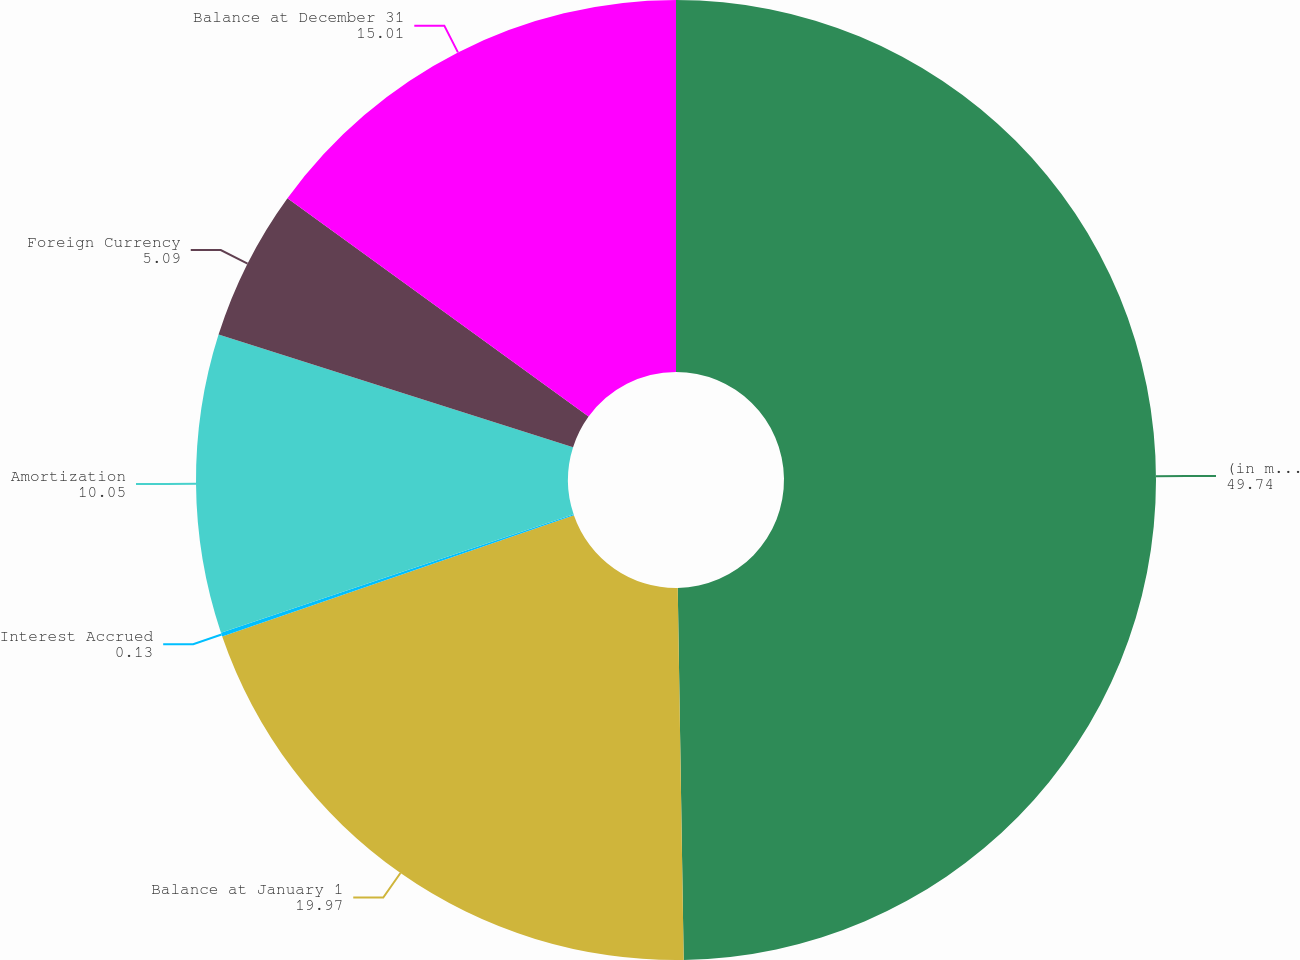Convert chart. <chart><loc_0><loc_0><loc_500><loc_500><pie_chart><fcel>(in millions of dollars)<fcel>Balance at January 1<fcel>Interest Accrued<fcel>Amortization<fcel>Foreign Currency<fcel>Balance at December 31<nl><fcel>49.74%<fcel>19.97%<fcel>0.13%<fcel>10.05%<fcel>5.09%<fcel>15.01%<nl></chart> 